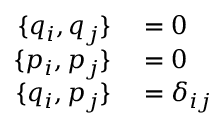Convert formula to latex. <formula><loc_0><loc_0><loc_500><loc_500>\begin{array} { r l } { \{ q _ { i } , q _ { j } \} } & = 0 } \\ { \{ p _ { i } , p _ { j } \} } & = 0 } \\ { \{ q _ { i } , p _ { j } \} } & = \delta _ { i j } } \end{array}</formula> 